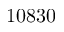Convert formula to latex. <formula><loc_0><loc_0><loc_500><loc_500>1 0 8 3 0</formula> 